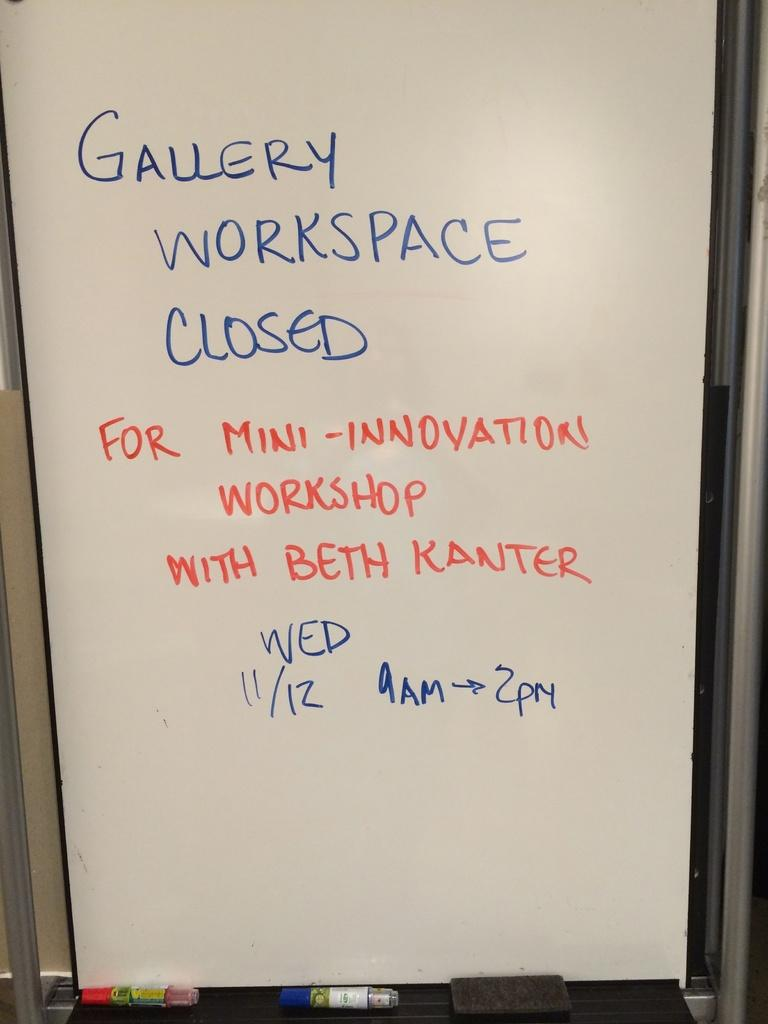<image>
Give a short and clear explanation of the subsequent image. A sign about the Gallery Workspace being closed 